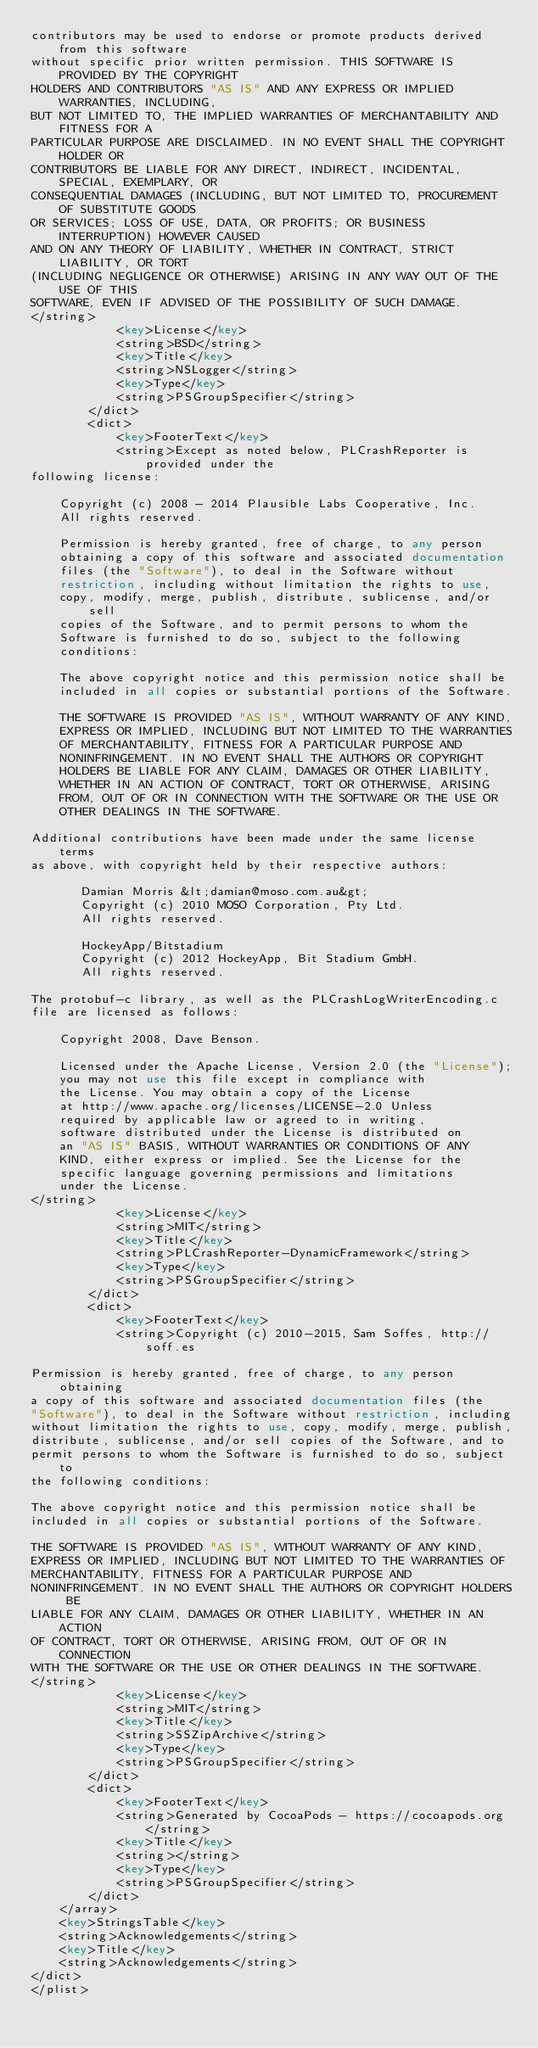<code> <loc_0><loc_0><loc_500><loc_500><_XML_>contributors may be used to endorse or promote products derived from this software
without specific prior written permission. THIS SOFTWARE IS PROVIDED BY THE COPYRIGHT
HOLDERS AND CONTRIBUTORS "AS IS" AND ANY EXPRESS OR IMPLIED WARRANTIES, INCLUDING,
BUT NOT LIMITED TO, THE IMPLIED WARRANTIES OF MERCHANTABILITY AND FITNESS FOR A
PARTICULAR PURPOSE ARE DISCLAIMED. IN NO EVENT SHALL THE COPYRIGHT HOLDER OR
CONTRIBUTORS BE LIABLE FOR ANY DIRECT, INDIRECT, INCIDENTAL, SPECIAL, EXEMPLARY, OR
CONSEQUENTIAL DAMAGES (INCLUDING, BUT NOT LIMITED TO, PROCUREMENT OF SUBSTITUTE GOODS
OR SERVICES; LOSS OF USE, DATA, OR PROFITS; OR BUSINESS INTERRUPTION) HOWEVER CAUSED
AND ON ANY THEORY OF LIABILITY, WHETHER IN CONTRACT, STRICT LIABILITY, OR TORT
(INCLUDING NEGLIGENCE OR OTHERWISE) ARISING IN ANY WAY OUT OF THE USE OF THIS
SOFTWARE, EVEN IF ADVISED OF THE POSSIBILITY OF SUCH DAMAGE.
</string>
			<key>License</key>
			<string>BSD</string>
			<key>Title</key>
			<string>NSLogger</string>
			<key>Type</key>
			<string>PSGroupSpecifier</string>
		</dict>
		<dict>
			<key>FooterText</key>
			<string>Except as noted below, PLCrashReporter is provided under the
following license:

    Copyright (c) 2008 - 2014 Plausible Labs Cooperative, Inc.
    All rights reserved.

    Permission is hereby granted, free of charge, to any person
    obtaining a copy of this software and associated documentation
    files (the "Software"), to deal in the Software without
    restriction, including without limitation the rights to use,
    copy, modify, merge, publish, distribute, sublicense, and/or sell
    copies of the Software, and to permit persons to whom the
    Software is furnished to do so, subject to the following
    conditions:

    The above copyright notice and this permission notice shall be
    included in all copies or substantial portions of the Software.

    THE SOFTWARE IS PROVIDED "AS IS", WITHOUT WARRANTY OF ANY KIND,
    EXPRESS OR IMPLIED, INCLUDING BUT NOT LIMITED TO THE WARRANTIES
    OF MERCHANTABILITY, FITNESS FOR A PARTICULAR PURPOSE AND
    NONINFRINGEMENT. IN NO EVENT SHALL THE AUTHORS OR COPYRIGHT
    HOLDERS BE LIABLE FOR ANY CLAIM, DAMAGES OR OTHER LIABILITY,
    WHETHER IN AN ACTION OF CONTRACT, TORT OR OTHERWISE, ARISING
    FROM, OUT OF OR IN CONNECTION WITH THE SOFTWARE OR THE USE OR
    OTHER DEALINGS IN THE SOFTWARE.

Additional contributions have been made under the same license terms
as above, with copyright held by their respective authors:

       Damian Morris &lt;damian@moso.com.au&gt;
       Copyright (c) 2010 MOSO Corporation, Pty Ltd.
       All rights reserved.

       HockeyApp/Bitstadium
       Copyright (c) 2012 HockeyApp, Bit Stadium GmbH.
       All rights reserved.

The protobuf-c library, as well as the PLCrashLogWriterEncoding.c
file are licensed as follows:

    Copyright 2008, Dave Benson.

    Licensed under the Apache License, Version 2.0 (the "License");
    you may not use this file except in compliance with
    the License. You may obtain a copy of the License
    at http://www.apache.org/licenses/LICENSE-2.0 Unless
    required by applicable law or agreed to in writing,
    software distributed under the License is distributed on
    an "AS IS" BASIS, WITHOUT WARRANTIES OR CONDITIONS OF ANY
    KIND, either express or implied. See the License for the
    specific language governing permissions and limitations
    under the License.
</string>
			<key>License</key>
			<string>MIT</string>
			<key>Title</key>
			<string>PLCrashReporter-DynamicFramework</string>
			<key>Type</key>
			<string>PSGroupSpecifier</string>
		</dict>
		<dict>
			<key>FooterText</key>
			<string>Copyright (c) 2010-2015, Sam Soffes, http://soff.es

Permission is hereby granted, free of charge, to any person obtaining
a copy of this software and associated documentation files (the
"Software"), to deal in the Software without restriction, including
without limitation the rights to use, copy, modify, merge, publish,
distribute, sublicense, and/or sell copies of the Software, and to
permit persons to whom the Software is furnished to do so, subject to
the following conditions:

The above copyright notice and this permission notice shall be
included in all copies or substantial portions of the Software.

THE SOFTWARE IS PROVIDED "AS IS", WITHOUT WARRANTY OF ANY KIND,
EXPRESS OR IMPLIED, INCLUDING BUT NOT LIMITED TO THE WARRANTIES OF
MERCHANTABILITY, FITNESS FOR A PARTICULAR PURPOSE AND
NONINFRINGEMENT. IN NO EVENT SHALL THE AUTHORS OR COPYRIGHT HOLDERS BE
LIABLE FOR ANY CLAIM, DAMAGES OR OTHER LIABILITY, WHETHER IN AN ACTION
OF CONTRACT, TORT OR OTHERWISE, ARISING FROM, OUT OF OR IN CONNECTION
WITH THE SOFTWARE OR THE USE OR OTHER DEALINGS IN THE SOFTWARE.
</string>
			<key>License</key>
			<string>MIT</string>
			<key>Title</key>
			<string>SSZipArchive</string>
			<key>Type</key>
			<string>PSGroupSpecifier</string>
		</dict>
		<dict>
			<key>FooterText</key>
			<string>Generated by CocoaPods - https://cocoapods.org</string>
			<key>Title</key>
			<string></string>
			<key>Type</key>
			<string>PSGroupSpecifier</string>
		</dict>
	</array>
	<key>StringsTable</key>
	<string>Acknowledgements</string>
	<key>Title</key>
	<string>Acknowledgements</string>
</dict>
</plist>
</code> 